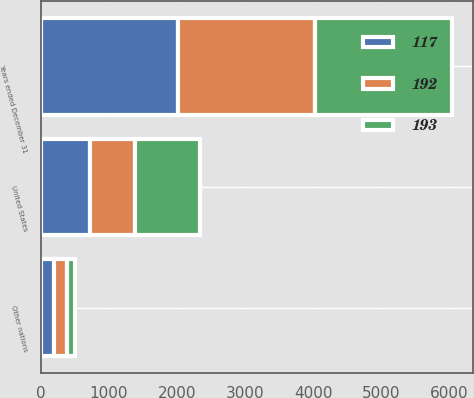<chart> <loc_0><loc_0><loc_500><loc_500><stacked_bar_chart><ecel><fcel>Years ended December 31<fcel>United States<fcel>Other nations<nl><fcel>193<fcel>2017<fcel>959<fcel>117<nl><fcel>192<fcel>2016<fcel>651<fcel>193<nl><fcel>117<fcel>2015<fcel>725<fcel>192<nl></chart> 